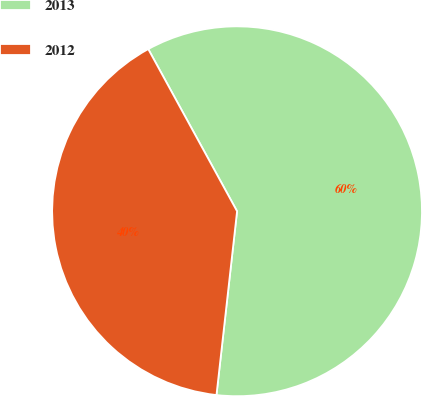Convert chart. <chart><loc_0><loc_0><loc_500><loc_500><pie_chart><fcel>2013<fcel>2012<nl><fcel>59.75%<fcel>40.25%<nl></chart> 